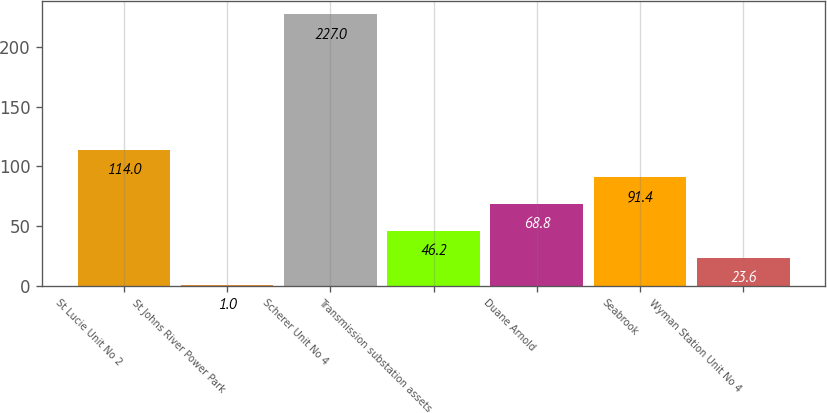Convert chart. <chart><loc_0><loc_0><loc_500><loc_500><bar_chart><fcel>St Lucie Unit No 2<fcel>St Johns River Power Park<fcel>Scherer Unit No 4<fcel>Transmission substation assets<fcel>Duane Arnold<fcel>Seabrook<fcel>Wyman Station Unit No 4<nl><fcel>114<fcel>1<fcel>227<fcel>46.2<fcel>68.8<fcel>91.4<fcel>23.6<nl></chart> 